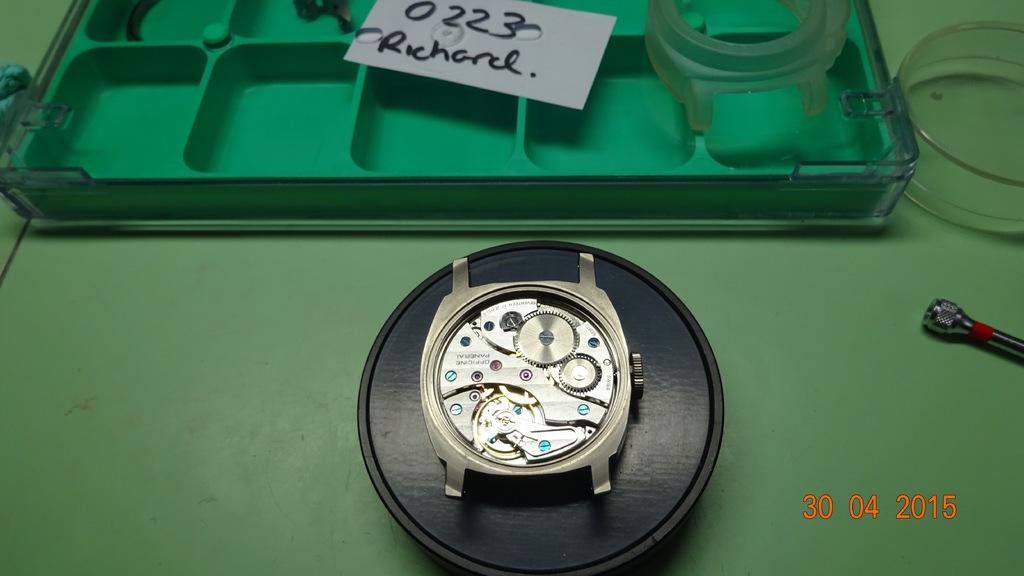The name on the tag is who?
Offer a very short reply. Richard. What day was the picture taken?
Keep it short and to the point. 30 04 2015. 